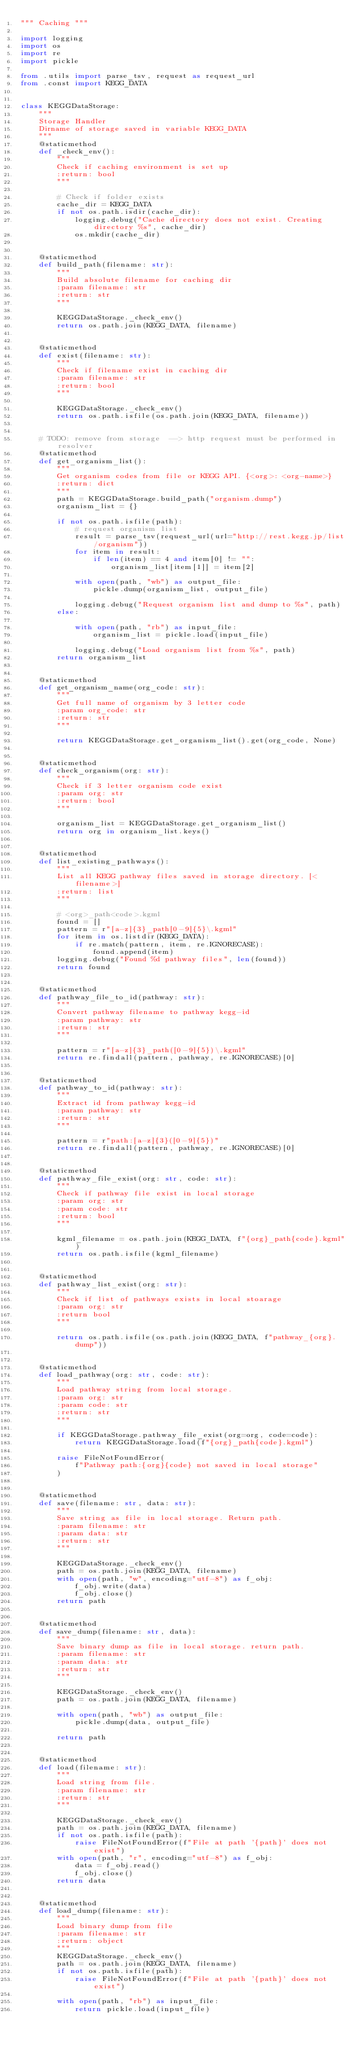Convert code to text. <code><loc_0><loc_0><loc_500><loc_500><_Python_>""" Caching """

import logging
import os
import re
import pickle

from .utils import parse_tsv, request as request_url
from .const import KEGG_DATA


class KEGGDataStorage:
    """
    Storage Handler
    Dirname of storage saved in variable KEGG_DATA
    """
    @staticmethod
    def _check_env():
        """
        Check if caching environment is set up
        :return: bool
        """

        # Check if folder exists
        cache_dir = KEGG_DATA
        if not os.path.isdir(cache_dir):
            logging.debug("Cache directory does not exist. Creating directory %s", cache_dir)
            os.mkdir(cache_dir)


    @staticmethod
    def build_path(filename: str):
        """
        Build absolute filename for caching dir
        :param filename: str
        :return: str
        """

        KEGGDataStorage._check_env()
        return os.path.join(KEGG_DATA, filename)


    @staticmethod
    def exist(filename: str):
        """
        Check if filename exist in caching dir
        :param filename: str
        :return: bool
        """

        KEGGDataStorage._check_env()
        return os.path.isfile(os.path.join(KEGG_DATA, filename))


    # TODO: remove from storage  --> http request must be performed in resolver
    @staticmethod
    def get_organism_list():
        """
        Get organism codes from file or KEGG API. {<org>: <org-name>}
        :return: dict
        """
        path = KEGGDataStorage.build_path("organism.dump")
        organism_list = {}

        if not os.path.isfile(path):
            # request organism list
            result = parse_tsv(request_url(url="http://rest.kegg.jp/list/organism"))
            for item in result:
                if len(item) == 4 and item[0] != "":
                    organism_list[item[1]] = item[2]

            with open(path, "wb") as output_file:
                pickle.dump(organism_list, output_file)

            logging.debug("Request organism list and dump to %s", path)
        else:

            with open(path, "rb") as input_file:
                organism_list = pickle.load(input_file)

            logging.debug("Load organism list from %s", path)
        return organism_list


    @staticmethod
    def get_organism_name(org_code: str):
        """
        Get full name of organism by 3 letter code
        :param org_code: str
        :return: str
        """

        return KEGGDataStorage.get_organism_list().get(org_code, None)


    @staticmethod
    def check_organism(org: str):
        """
        Check if 3 letter organism code exist
        :param org: str
        :return: bool
        """

        organism_list = KEGGDataStorage.get_organism_list()
        return org in organism_list.keys()


    @staticmethod
    def list_existing_pathways():
        """
        List all KEGG pathway files saved in storage directory. [<filename>]
        :return: list
        """

        # <org>_path<code>.kgml
        found = []
        pattern = r"[a-z]{3}_path[0-9]{5}\.kgml"
        for item in os.listdir(KEGG_DATA):
            if re.match(pattern, item, re.IGNORECASE):
                found.append(item)
        logging.debug("Found %d pathway files", len(found))
        return found


    @staticmethod
    def pathway_file_to_id(pathway: str):
        """
        Convert pathway filename to pathway kegg-id
        :param pathway: str
        :return: str
        """

        pattern = r"[a-z]{3}_path([0-9]{5})\.kgml"
        return re.findall(pattern, pathway, re.IGNORECASE)[0]


    @staticmethod
    def pathway_to_id(pathway: str):
        """
        Extract id from pathway kegg-id
        :param pathway: str
        :return: str
        """

        pattern = r"path:[a-z]{3}([0-9]{5})"
        return re.findall(pattern, pathway, re.IGNORECASE)[0]


    @staticmethod
    def pathway_file_exist(org: str, code: str):
        """
        Check if pathway file exist in local storage
        :param org: str
        :param code: str
        :return: bool
        """

        kgml_filename = os.path.join(KEGG_DATA, f"{org}_path{code}.kgml")
        return os.path.isfile(kgml_filename)


    @staticmethod
    def pathway_list_exist(org: str):
        """
        Check if list of pathways exists in local stoarage
        :param org: str
        :return bool
        """

        return os.path.isfile(os.path.join(KEGG_DATA, f"pathway_{org}.dump"))


    @staticmethod
    def load_pathway(org: str, code: str):
        """
        Load pathway string from local storage.
        :param org: str
        :param code: str
        :return: str
        """

        if KEGGDataStorage.pathway_file_exist(org=org, code=code):
            return KEGGDataStorage.load(f"{org}_path{code}.kgml")

        raise FileNotFoundError(
            f"Pathway path:{org}{code} not saved in local storage"
        )


    @staticmethod
    def save(filename: str, data: str):
        """
        Save string as file in local storage. Return path.
        :param filename: str
        :param data: str
        :return: str
        """

        KEGGDataStorage._check_env()
        path = os.path.join(KEGG_DATA, filename)
        with open(path, "w", encoding="utf-8") as f_obj:
            f_obj.write(data)
            f_obj.close()
        return path


    @staticmethod
    def save_dump(filename: str, data):
        """
        Save binary dump as file in local storage. return path.
        :param filename: str
        :param data: str
        :return: str
        """

        KEGGDataStorage._check_env()
        path = os.path.join(KEGG_DATA, filename)

        with open(path, "wb") as output_file:
            pickle.dump(data, output_file)

        return path


    @staticmethod
    def load(filename: str):
        """
        Load string from file.
        :param filename: str
        :return: str
        """

        KEGGDataStorage._check_env()
        path = os.path.join(KEGG_DATA, filename)
        if not os.path.isfile(path):
            raise FileNotFoundError(f"File at path '{path}' does not exist")
        with open(path, "r", encoding="utf-8") as f_obj:
            data = f_obj.read()
            f_obj.close()
        return data


    @staticmethod
    def load_dump(filename: str):
        """
        Load binary dump from file
        :param filename: str
        :return: object
        """
        KEGGDataStorage._check_env()
        path = os.path.join(KEGG_DATA, filename)
        if not os.path.isfile(path):
            raise FileNotFoundError(f"File at path '{path}' does not exist")

        with open(path, "rb") as input_file:
            return pickle.load(input_file)

</code> 